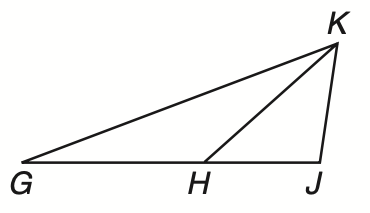Question: If G H \cong H K, H J \cong Y K, and m \angle G J K = 100, what is the measure of \angle H G K?
Choices:
A. 10
B. 15
C. 20
D. 25
Answer with the letter. Answer: C 